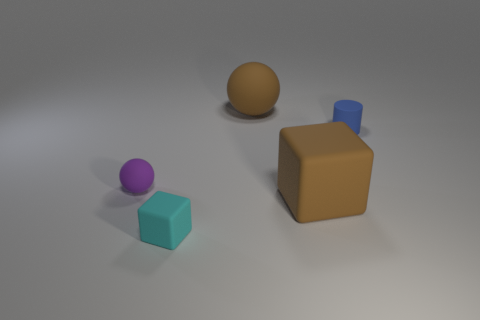Does the large rubber sphere have the same color as the big cube?
Provide a succinct answer. Yes. There is a big object in front of the large brown rubber ball; does it have the same color as the big ball?
Give a very brief answer. Yes. How many cylinders are either tiny things or brown matte objects?
Your response must be concise. 1. The brown thing that is in front of the big thing to the left of the large rubber cube is what shape?
Keep it short and to the point. Cube. What is the size of the object that is left of the rubber cube on the left side of the big matte thing that is to the left of the large brown matte cube?
Give a very brief answer. Small. Does the blue rubber cylinder have the same size as the cyan matte cube?
Your response must be concise. Yes. What number of objects are either small purple balls or tiny blocks?
Offer a terse response. 2. There is a matte sphere in front of the large thing behind the cylinder; what size is it?
Offer a terse response. Small. How big is the cyan rubber cube?
Keep it short and to the point. Small. The small matte object that is to the right of the purple matte object and behind the big brown rubber block has what shape?
Give a very brief answer. Cylinder. 